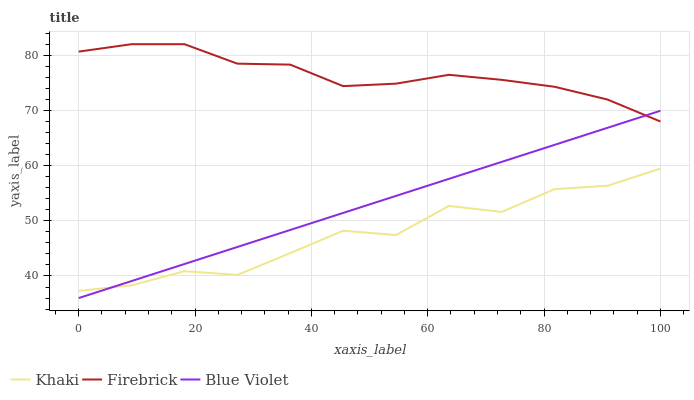Does Khaki have the minimum area under the curve?
Answer yes or no. Yes. Does Firebrick have the maximum area under the curve?
Answer yes or no. Yes. Does Blue Violet have the minimum area under the curve?
Answer yes or no. No. Does Blue Violet have the maximum area under the curve?
Answer yes or no. No. Is Blue Violet the smoothest?
Answer yes or no. Yes. Is Khaki the roughest?
Answer yes or no. Yes. Is Khaki the smoothest?
Answer yes or no. No. Is Blue Violet the roughest?
Answer yes or no. No. Does Blue Violet have the lowest value?
Answer yes or no. Yes. Does Khaki have the lowest value?
Answer yes or no. No. Does Firebrick have the highest value?
Answer yes or no. Yes. Does Blue Violet have the highest value?
Answer yes or no. No. Is Khaki less than Firebrick?
Answer yes or no. Yes. Is Firebrick greater than Khaki?
Answer yes or no. Yes. Does Blue Violet intersect Firebrick?
Answer yes or no. Yes. Is Blue Violet less than Firebrick?
Answer yes or no. No. Is Blue Violet greater than Firebrick?
Answer yes or no. No. Does Khaki intersect Firebrick?
Answer yes or no. No. 